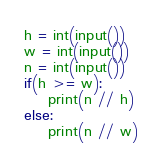Convert code to text. <code><loc_0><loc_0><loc_500><loc_500><_Python_>h = int(input())
w = int(input())
n = int(input())
if(h >= w):
    print(n // h)
else:
    print(n // w)</code> 